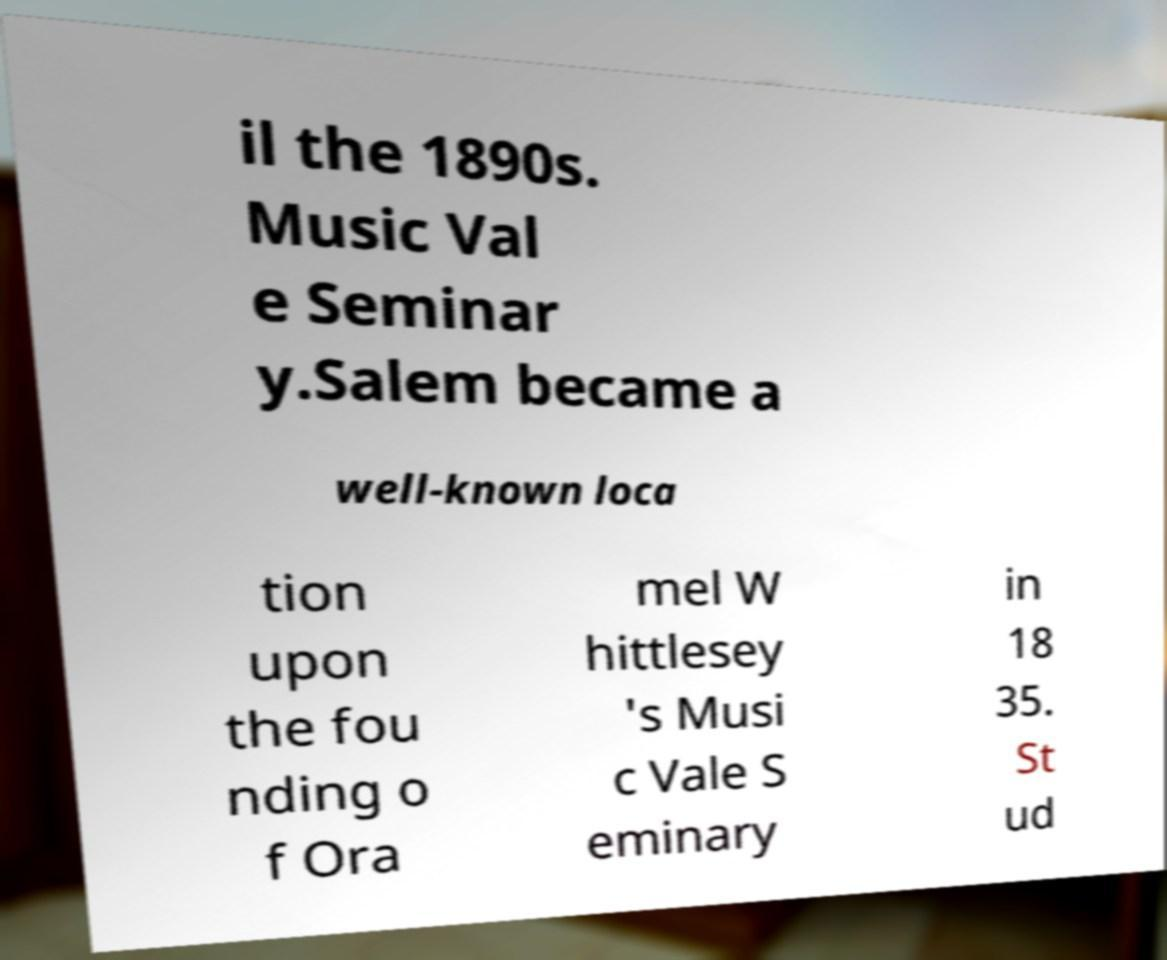I need the written content from this picture converted into text. Can you do that? il the 1890s. Music Val e Seminar y.Salem became a well-known loca tion upon the fou nding o f Ora mel W hittlesey 's Musi c Vale S eminary in 18 35. St ud 